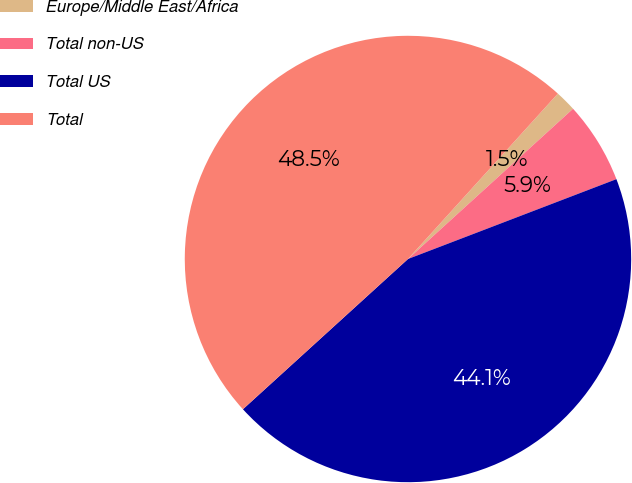<chart> <loc_0><loc_0><loc_500><loc_500><pie_chart><fcel>Europe/Middle East/Africa<fcel>Total non-US<fcel>Total US<fcel>Total<nl><fcel>1.53%<fcel>5.93%<fcel>44.07%<fcel>48.47%<nl></chart> 